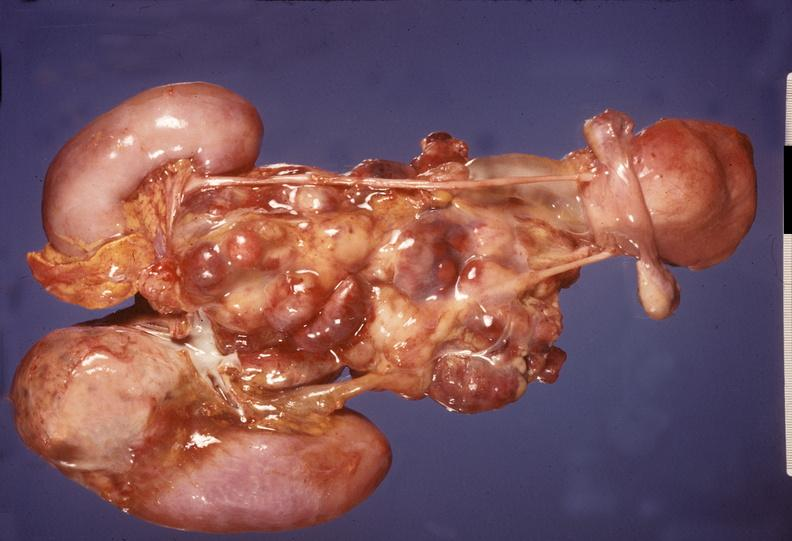where does this belong to?
Answer the question using a single word or phrase. Endocrine system 